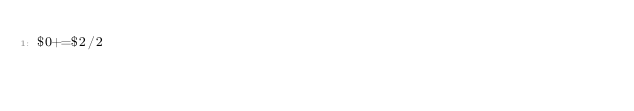Convert code to text. <code><loc_0><loc_0><loc_500><loc_500><_Awk_>$0+=$2/2</code> 